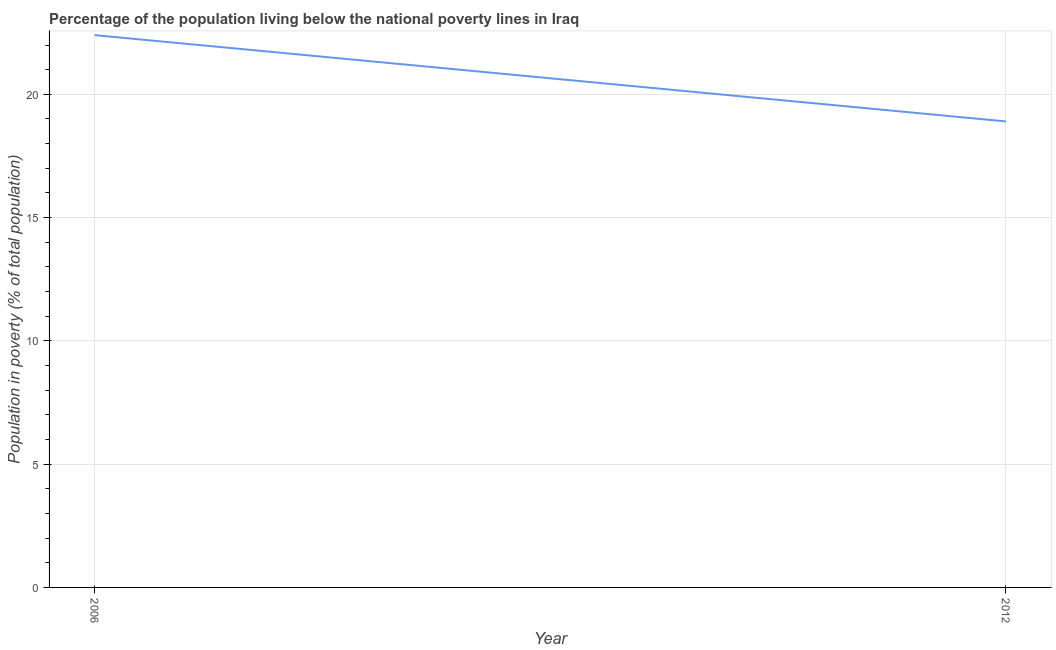What is the percentage of population living below poverty line in 2006?
Make the answer very short. 22.4. Across all years, what is the maximum percentage of population living below poverty line?
Offer a very short reply. 22.4. What is the sum of the percentage of population living below poverty line?
Your response must be concise. 41.3. What is the average percentage of population living below poverty line per year?
Provide a short and direct response. 20.65. What is the median percentage of population living below poverty line?
Offer a terse response. 20.65. What is the ratio of the percentage of population living below poverty line in 2006 to that in 2012?
Give a very brief answer. 1.19. In how many years, is the percentage of population living below poverty line greater than the average percentage of population living below poverty line taken over all years?
Make the answer very short. 1. How many years are there in the graph?
Make the answer very short. 2. Are the values on the major ticks of Y-axis written in scientific E-notation?
Your response must be concise. No. What is the title of the graph?
Offer a terse response. Percentage of the population living below the national poverty lines in Iraq. What is the label or title of the Y-axis?
Your response must be concise. Population in poverty (% of total population). What is the Population in poverty (% of total population) in 2006?
Your response must be concise. 22.4. What is the Population in poverty (% of total population) of 2012?
Offer a terse response. 18.9. What is the ratio of the Population in poverty (% of total population) in 2006 to that in 2012?
Your answer should be compact. 1.19. 